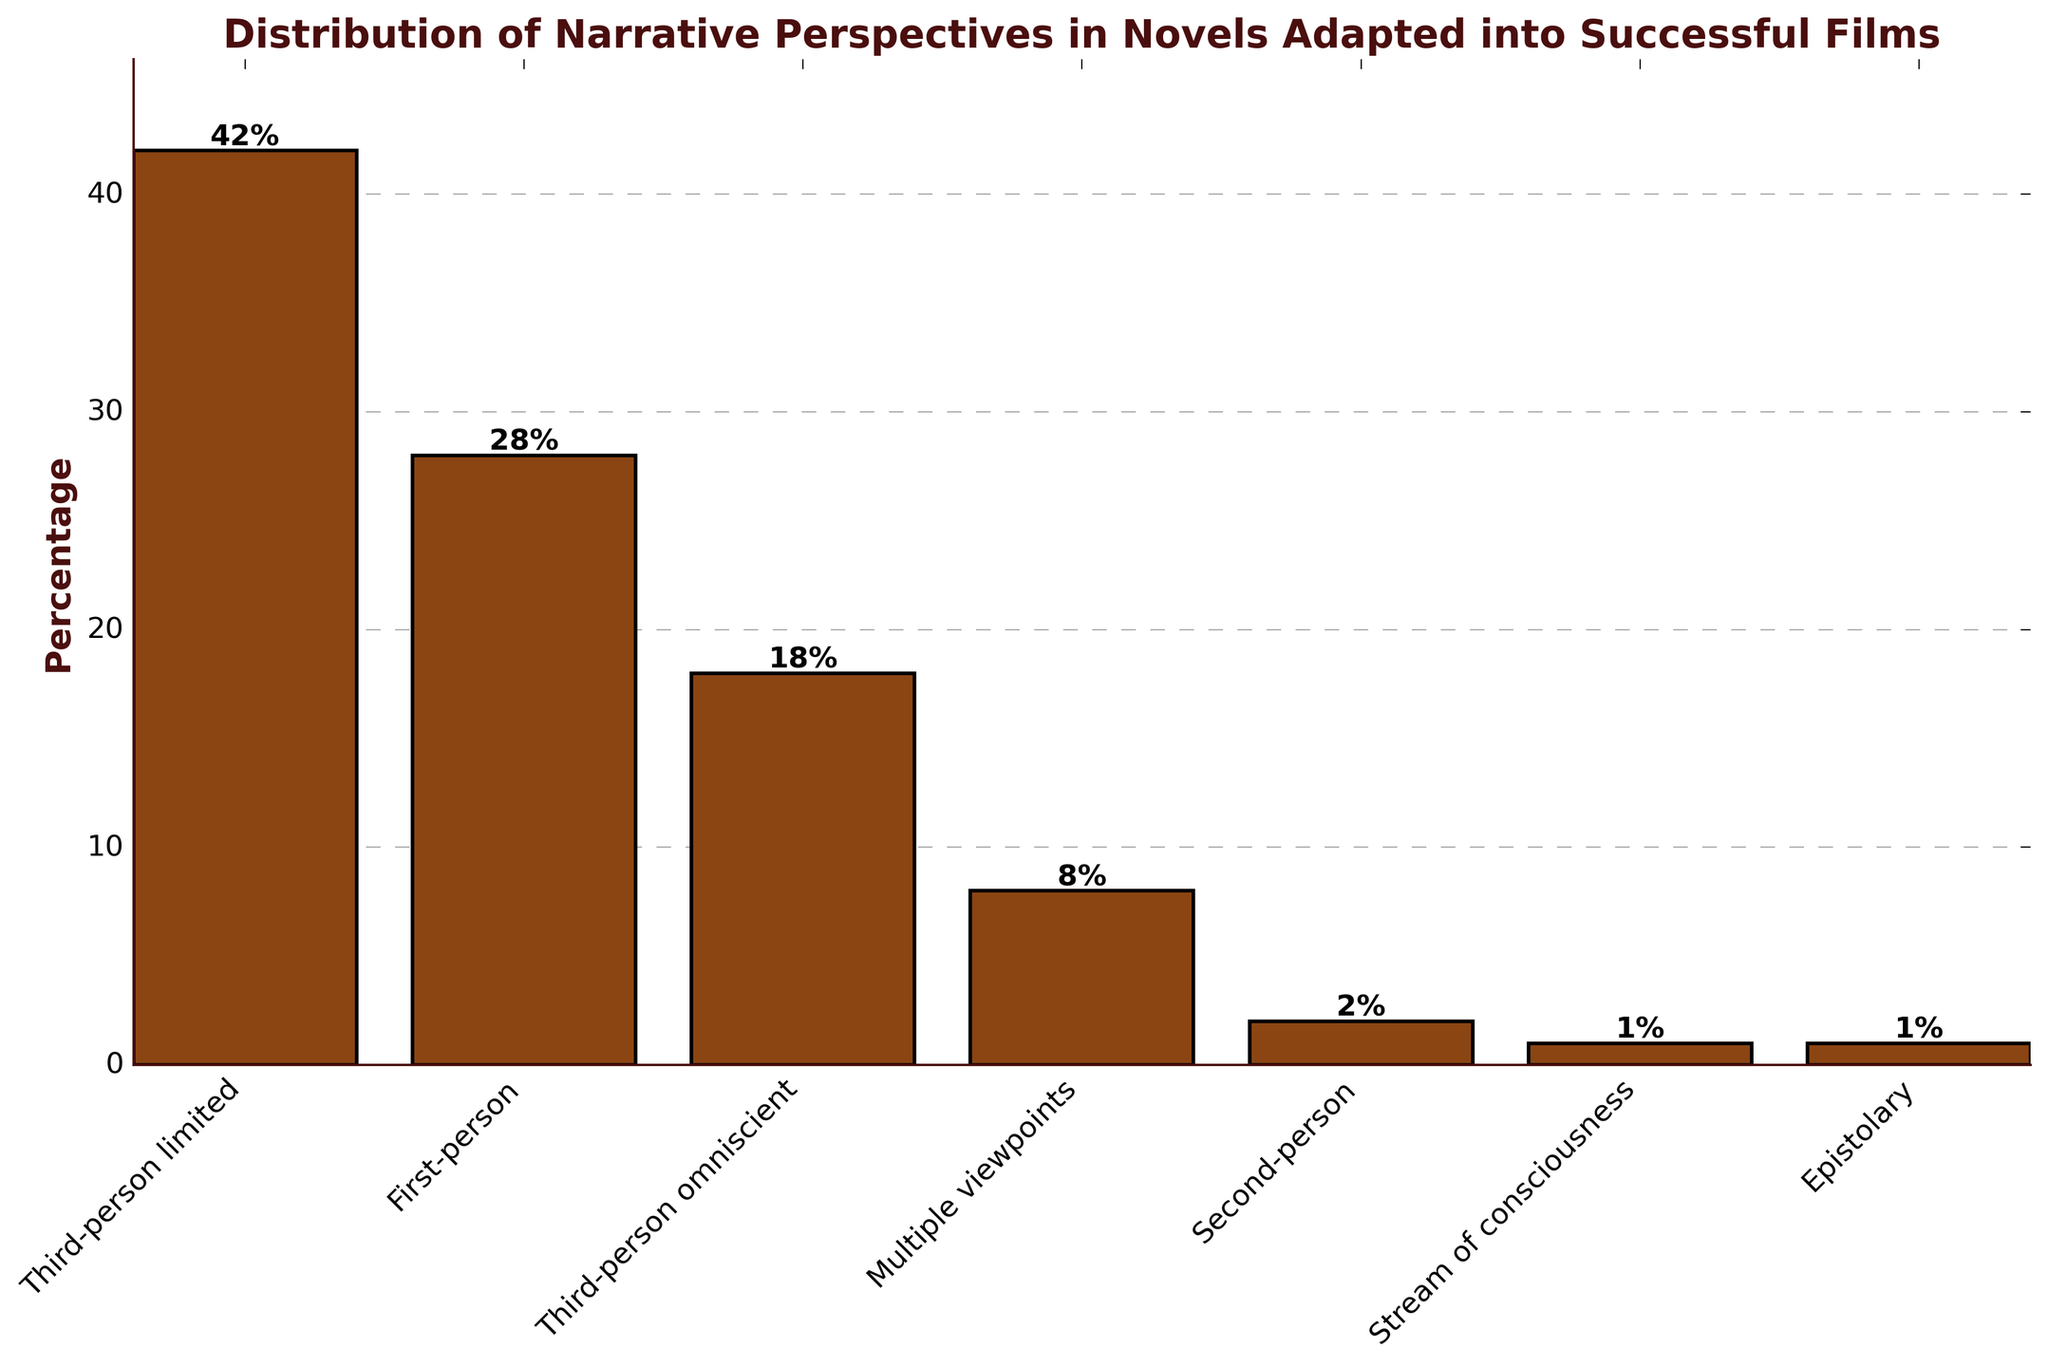Which narrative perspective has the highest percentage in the distribution? The bar labeled "Third-person limited" is the tallest bar, which signifies it has the highest percentage in the distribution.
Answer: Third-person limited Which visual attribute shows the percentage for each narrative perspective? The height of each bar represents the percentage for each narrative perspective, with taller bars indicating higher percentages.
Answer: Height How much more is the percentage of narrative perspectives in third-person limited compared to third-person omniscient? The percentage for third-person limited is 42%, and for third-person omniscient, it's 18%. The difference is 42% - 18% = 24%.
Answer: 24% Arrange the narrative perspectives in descending order of their percentages. The heights of the bars allow us to list them from tallest to shortest: Third-person limited (42%), First-person (28%), Third-person omniscient (18%), Multiple viewpoints (8%), Second-person (2%), Stream of consciousness (1%), Epistolary (1%).
Answer: Third-person limited, First-person, Third-person omniscient, Multiple viewpoints, Second-person, Stream of consciousness, Epistolary What is the combined percentage of second-person and stream of consciousness perspectives? The percentage for second-person is 2% and for stream of consciousness, it's 1%. Adding these gives 2% + 1% = 3%.
Answer: 3% Which narrative perspectives have the same percentage and what is that percentage? The bars for Stream of consciousness and Epistolary are at the same height, indicating they both have a percentage of 1%.
Answer: Stream of consciousness, Epistolary How does the percentage of multiple viewpoints compare to the percentage of first-person narratives? The percentage for multiple viewpoints is 8%, and for first-person, it's 28%. The first-person percentage is greater.
Answer: First-person is greater What percentage of the data falls under the category with the smallest value? The categories Stream of consciousness and Epistolary both have the smallest percentage value of 1%.
Answer: 1% What is the percentage difference between the least and the most common narrative perspectives? The least common narrative perspectives are Stream of consciousness and Epistolary at 1%, and the most common is Third-person limited at 42%. The difference is 42% - 1% = 41%.
Answer: 41% What's the sum of the percentages for first-person and third-person perspective categories combined (both limited and omniscient)? Adding the percentages for First-person (28%), Third-person limited (42%), and Third-person omniscient (18%), we get 28% + 42% + 18% = 88%.
Answer: 88% 